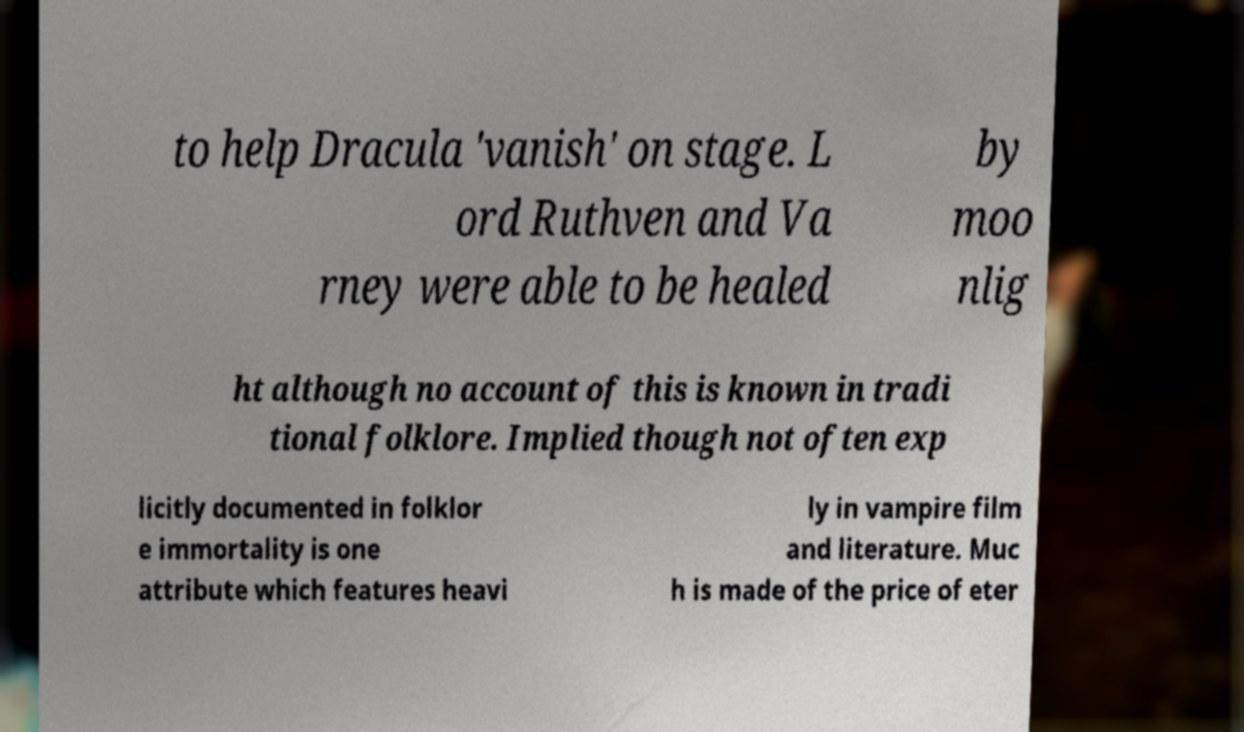I need the written content from this picture converted into text. Can you do that? to help Dracula 'vanish' on stage. L ord Ruthven and Va rney were able to be healed by moo nlig ht although no account of this is known in tradi tional folklore. Implied though not often exp licitly documented in folklor e immortality is one attribute which features heavi ly in vampire film and literature. Muc h is made of the price of eter 